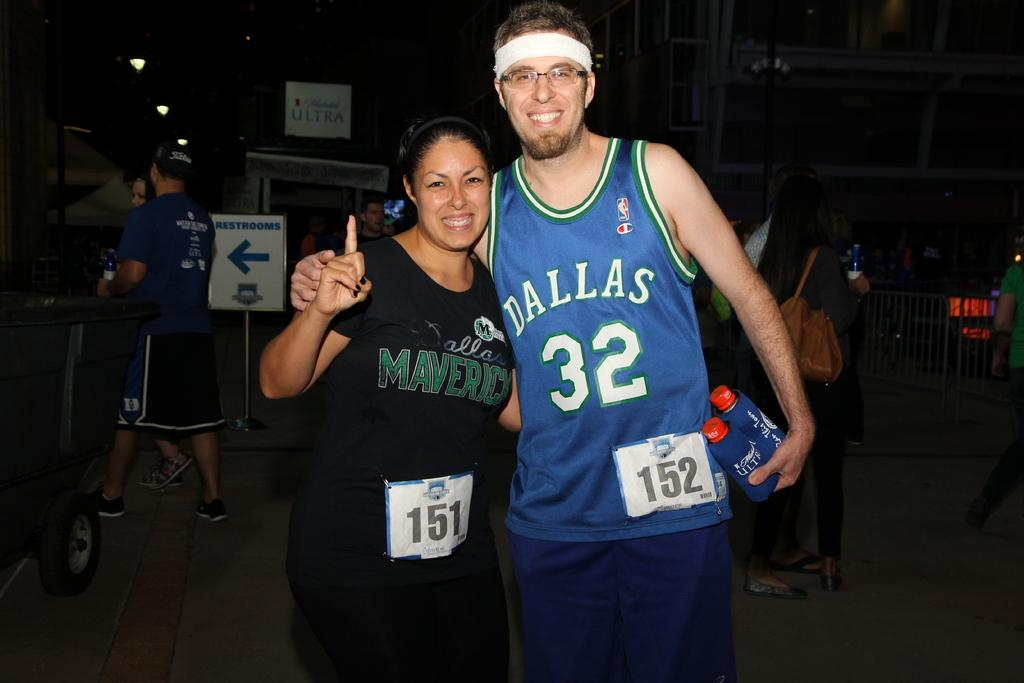<image>
Offer a succinct explanation of the picture presented. a man and a lady who are wearing Mavericks gear 